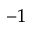Convert formula to latex. <formula><loc_0><loc_0><loc_500><loc_500>^ { - 1 }</formula> 